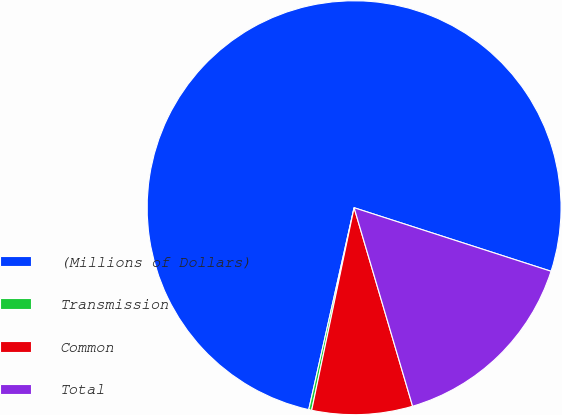Convert chart. <chart><loc_0><loc_0><loc_500><loc_500><pie_chart><fcel>(Millions of Dollars)<fcel>Transmission<fcel>Common<fcel>Total<nl><fcel>76.45%<fcel>0.23%<fcel>7.85%<fcel>15.47%<nl></chart> 